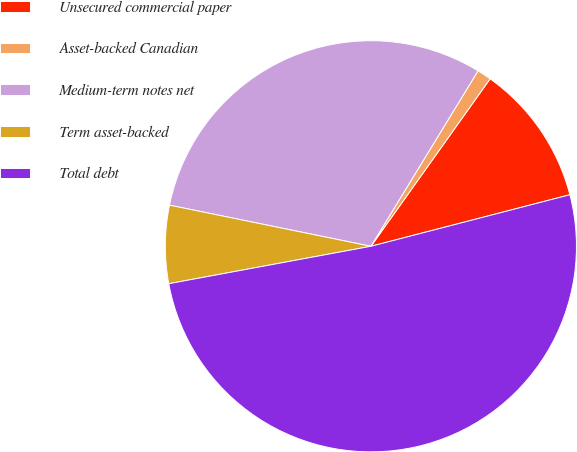<chart> <loc_0><loc_0><loc_500><loc_500><pie_chart><fcel>Unsecured commercial paper<fcel>Asset-backed Canadian<fcel>Medium-term notes net<fcel>Term asset-backed<fcel>Total debt<nl><fcel>11.12%<fcel>1.12%<fcel>30.52%<fcel>6.12%<fcel>51.12%<nl></chart> 